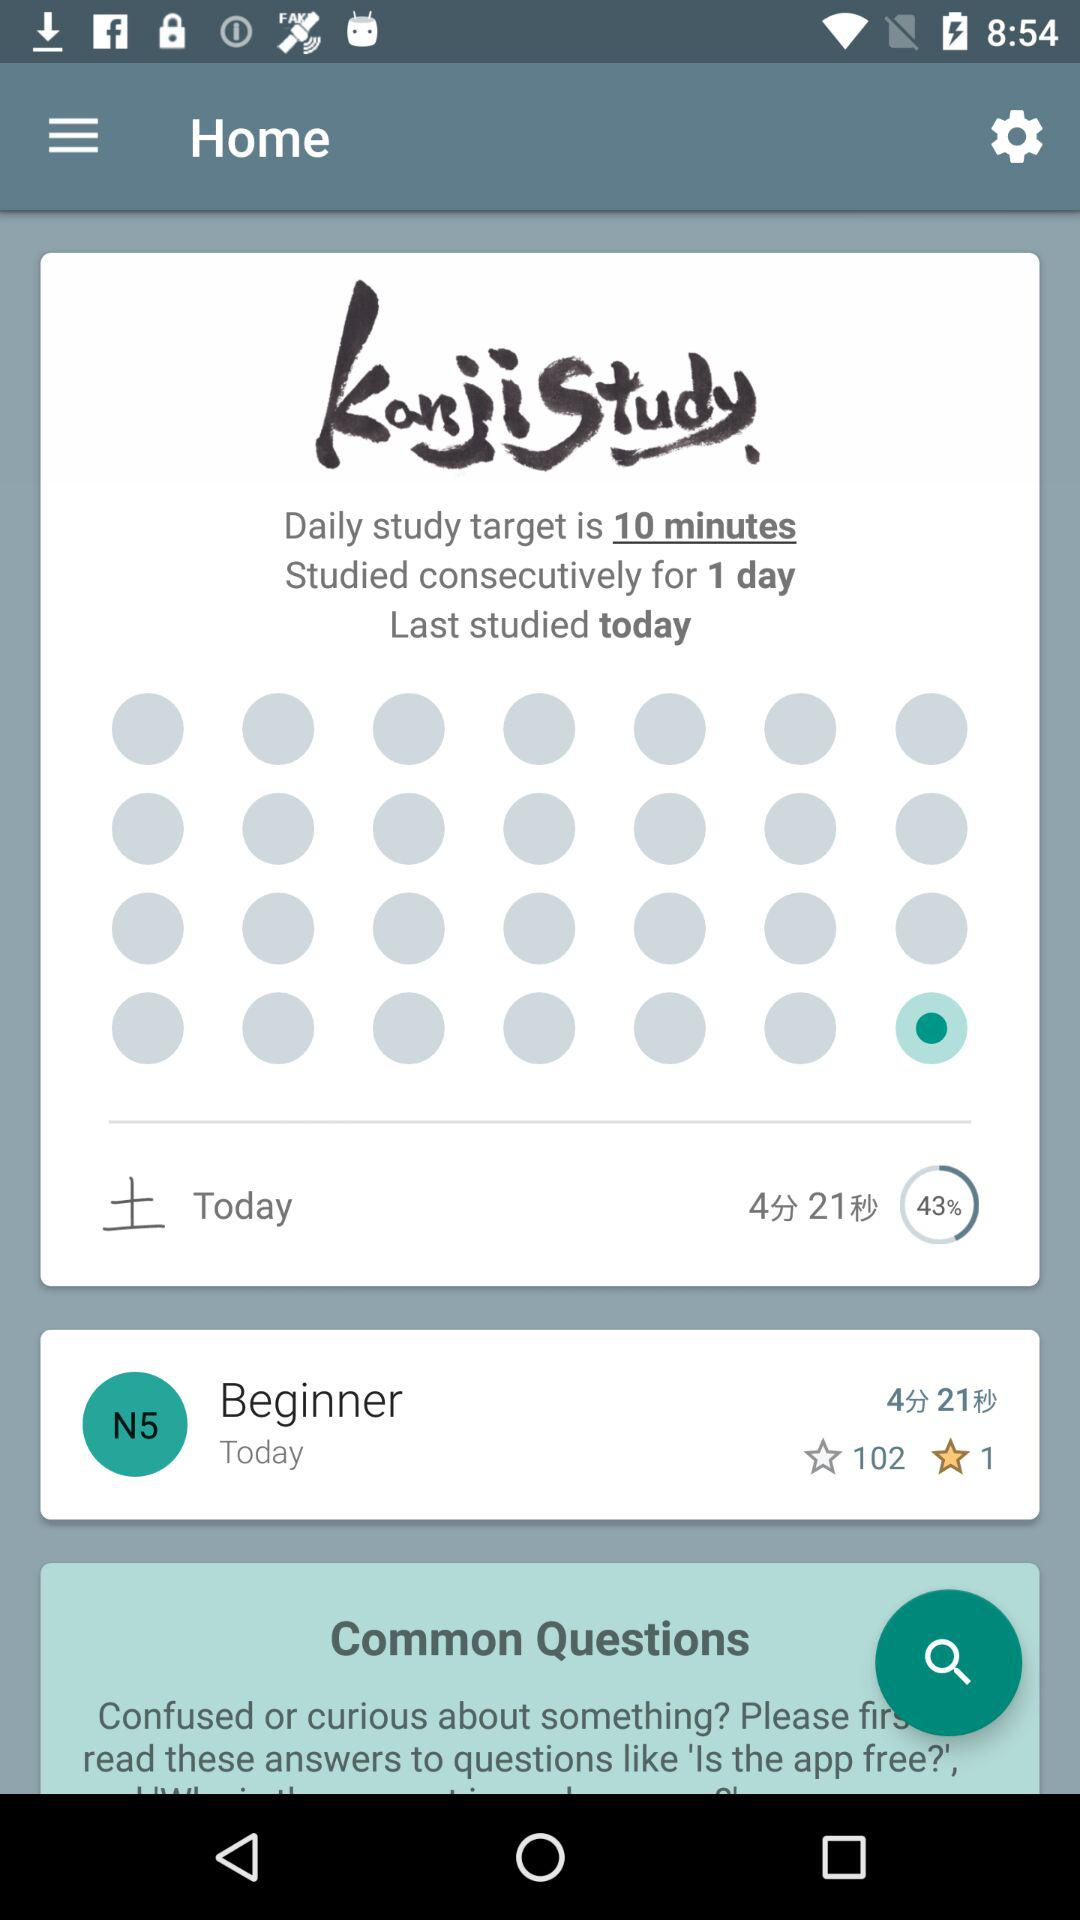How many days have I studied consecutively?
Answer the question using a single word or phrase. 1 day 